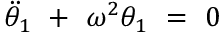Convert formula to latex. <formula><loc_0><loc_0><loc_500><loc_500>\ D d o t { \theta } _ { 1 } \ + \ \omega ^ { 2 } \theta _ { 1 } \ = \ 0</formula> 